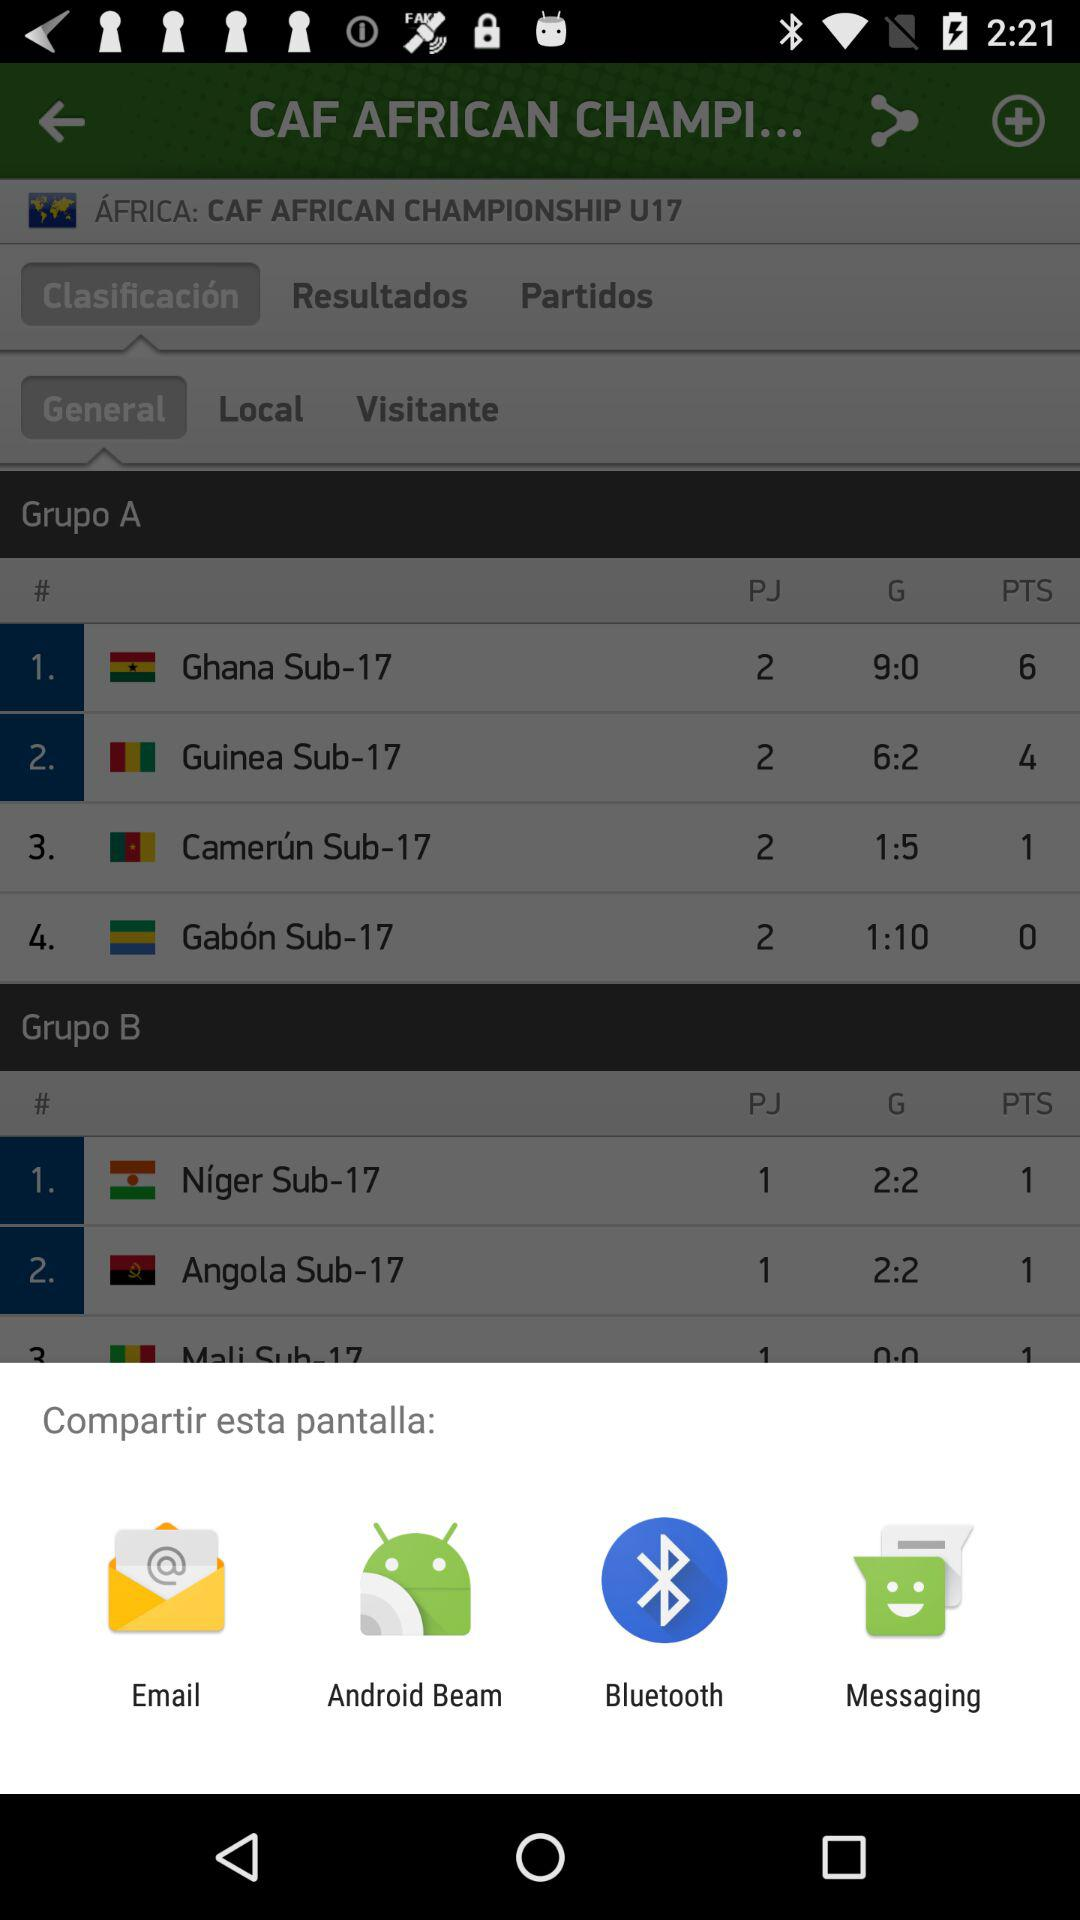How many more points does Mali Sub 17 have than Angola Sub-17?
Answer the question using a single word or phrase. 0 